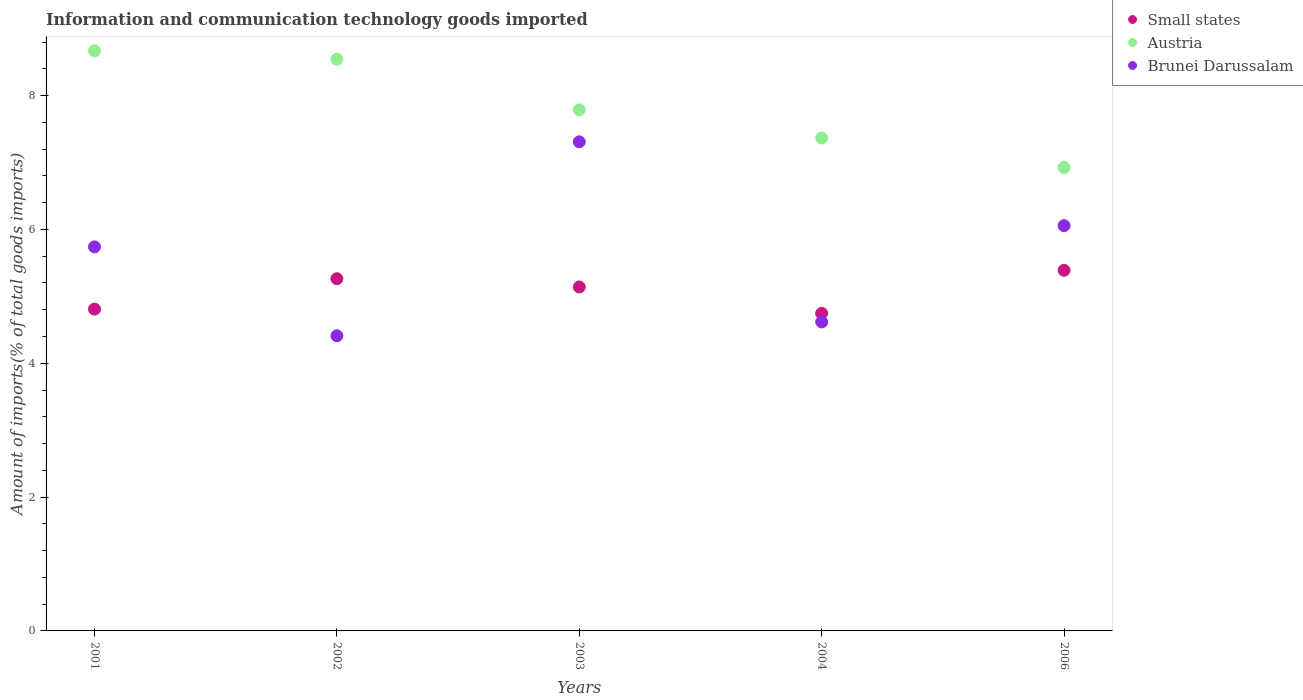What is the amount of goods imported in Small states in 2001?
Offer a very short reply. 4.81. Across all years, what is the maximum amount of goods imported in Brunei Darussalam?
Give a very brief answer. 7.31. Across all years, what is the minimum amount of goods imported in Small states?
Ensure brevity in your answer.  4.74. In which year was the amount of goods imported in Brunei Darussalam maximum?
Keep it short and to the point. 2003. What is the total amount of goods imported in Brunei Darussalam in the graph?
Keep it short and to the point. 28.13. What is the difference between the amount of goods imported in Austria in 2002 and that in 2006?
Make the answer very short. 1.62. What is the difference between the amount of goods imported in Austria in 2004 and the amount of goods imported in Small states in 2001?
Keep it short and to the point. 2.56. What is the average amount of goods imported in Austria per year?
Ensure brevity in your answer.  7.86. In the year 2004, what is the difference between the amount of goods imported in Austria and amount of goods imported in Brunei Darussalam?
Provide a succinct answer. 2.75. In how many years, is the amount of goods imported in Austria greater than 8.4 %?
Offer a very short reply. 2. What is the ratio of the amount of goods imported in Austria in 2003 to that in 2004?
Your response must be concise. 1.06. Is the amount of goods imported in Brunei Darussalam in 2003 less than that in 2004?
Keep it short and to the point. No. Is the difference between the amount of goods imported in Austria in 2003 and 2004 greater than the difference between the amount of goods imported in Brunei Darussalam in 2003 and 2004?
Offer a terse response. No. What is the difference between the highest and the second highest amount of goods imported in Brunei Darussalam?
Offer a terse response. 1.25. What is the difference between the highest and the lowest amount of goods imported in Austria?
Provide a short and direct response. 1.74. Does the amount of goods imported in Small states monotonically increase over the years?
Provide a short and direct response. No. Is the amount of goods imported in Brunei Darussalam strictly less than the amount of goods imported in Austria over the years?
Offer a very short reply. Yes. How many years are there in the graph?
Make the answer very short. 5. What is the difference between two consecutive major ticks on the Y-axis?
Provide a short and direct response. 2. Does the graph contain any zero values?
Give a very brief answer. No. How are the legend labels stacked?
Your answer should be compact. Vertical. What is the title of the graph?
Provide a short and direct response. Information and communication technology goods imported. What is the label or title of the Y-axis?
Offer a terse response. Amount of imports(% of total goods imports). What is the Amount of imports(% of total goods imports) of Small states in 2001?
Your answer should be very brief. 4.81. What is the Amount of imports(% of total goods imports) in Austria in 2001?
Provide a short and direct response. 8.67. What is the Amount of imports(% of total goods imports) of Brunei Darussalam in 2001?
Provide a succinct answer. 5.74. What is the Amount of imports(% of total goods imports) in Small states in 2002?
Provide a succinct answer. 5.26. What is the Amount of imports(% of total goods imports) in Austria in 2002?
Make the answer very short. 8.54. What is the Amount of imports(% of total goods imports) in Brunei Darussalam in 2002?
Keep it short and to the point. 4.41. What is the Amount of imports(% of total goods imports) in Small states in 2003?
Give a very brief answer. 5.14. What is the Amount of imports(% of total goods imports) of Austria in 2003?
Your answer should be compact. 7.79. What is the Amount of imports(% of total goods imports) in Brunei Darussalam in 2003?
Your answer should be compact. 7.31. What is the Amount of imports(% of total goods imports) in Small states in 2004?
Keep it short and to the point. 4.74. What is the Amount of imports(% of total goods imports) in Austria in 2004?
Offer a terse response. 7.37. What is the Amount of imports(% of total goods imports) of Brunei Darussalam in 2004?
Your answer should be very brief. 4.62. What is the Amount of imports(% of total goods imports) of Small states in 2006?
Ensure brevity in your answer.  5.39. What is the Amount of imports(% of total goods imports) of Austria in 2006?
Your answer should be very brief. 6.93. What is the Amount of imports(% of total goods imports) of Brunei Darussalam in 2006?
Make the answer very short. 6.06. Across all years, what is the maximum Amount of imports(% of total goods imports) in Small states?
Provide a succinct answer. 5.39. Across all years, what is the maximum Amount of imports(% of total goods imports) of Austria?
Your response must be concise. 8.67. Across all years, what is the maximum Amount of imports(% of total goods imports) in Brunei Darussalam?
Offer a very short reply. 7.31. Across all years, what is the minimum Amount of imports(% of total goods imports) of Small states?
Provide a short and direct response. 4.74. Across all years, what is the minimum Amount of imports(% of total goods imports) of Austria?
Your response must be concise. 6.93. Across all years, what is the minimum Amount of imports(% of total goods imports) in Brunei Darussalam?
Your answer should be very brief. 4.41. What is the total Amount of imports(% of total goods imports) of Small states in the graph?
Offer a terse response. 25.34. What is the total Amount of imports(% of total goods imports) in Austria in the graph?
Your answer should be compact. 39.29. What is the total Amount of imports(% of total goods imports) of Brunei Darussalam in the graph?
Make the answer very short. 28.13. What is the difference between the Amount of imports(% of total goods imports) of Small states in 2001 and that in 2002?
Offer a very short reply. -0.45. What is the difference between the Amount of imports(% of total goods imports) in Austria in 2001 and that in 2002?
Your answer should be very brief. 0.13. What is the difference between the Amount of imports(% of total goods imports) in Brunei Darussalam in 2001 and that in 2002?
Your answer should be compact. 1.33. What is the difference between the Amount of imports(% of total goods imports) of Small states in 2001 and that in 2003?
Offer a terse response. -0.33. What is the difference between the Amount of imports(% of total goods imports) of Austria in 2001 and that in 2003?
Offer a terse response. 0.88. What is the difference between the Amount of imports(% of total goods imports) of Brunei Darussalam in 2001 and that in 2003?
Make the answer very short. -1.57. What is the difference between the Amount of imports(% of total goods imports) in Small states in 2001 and that in 2004?
Provide a succinct answer. 0.06. What is the difference between the Amount of imports(% of total goods imports) in Austria in 2001 and that in 2004?
Provide a succinct answer. 1.3. What is the difference between the Amount of imports(% of total goods imports) of Brunei Darussalam in 2001 and that in 2004?
Offer a terse response. 1.12. What is the difference between the Amount of imports(% of total goods imports) of Small states in 2001 and that in 2006?
Provide a short and direct response. -0.58. What is the difference between the Amount of imports(% of total goods imports) in Austria in 2001 and that in 2006?
Your answer should be compact. 1.74. What is the difference between the Amount of imports(% of total goods imports) in Brunei Darussalam in 2001 and that in 2006?
Give a very brief answer. -0.32. What is the difference between the Amount of imports(% of total goods imports) of Small states in 2002 and that in 2003?
Provide a succinct answer. 0.12. What is the difference between the Amount of imports(% of total goods imports) of Austria in 2002 and that in 2003?
Provide a succinct answer. 0.76. What is the difference between the Amount of imports(% of total goods imports) in Brunei Darussalam in 2002 and that in 2003?
Ensure brevity in your answer.  -2.9. What is the difference between the Amount of imports(% of total goods imports) in Small states in 2002 and that in 2004?
Make the answer very short. 0.52. What is the difference between the Amount of imports(% of total goods imports) in Austria in 2002 and that in 2004?
Offer a terse response. 1.18. What is the difference between the Amount of imports(% of total goods imports) in Brunei Darussalam in 2002 and that in 2004?
Keep it short and to the point. -0.21. What is the difference between the Amount of imports(% of total goods imports) in Small states in 2002 and that in 2006?
Keep it short and to the point. -0.13. What is the difference between the Amount of imports(% of total goods imports) in Austria in 2002 and that in 2006?
Give a very brief answer. 1.62. What is the difference between the Amount of imports(% of total goods imports) in Brunei Darussalam in 2002 and that in 2006?
Keep it short and to the point. -1.65. What is the difference between the Amount of imports(% of total goods imports) in Small states in 2003 and that in 2004?
Your response must be concise. 0.39. What is the difference between the Amount of imports(% of total goods imports) in Austria in 2003 and that in 2004?
Offer a very short reply. 0.42. What is the difference between the Amount of imports(% of total goods imports) in Brunei Darussalam in 2003 and that in 2004?
Your answer should be very brief. 2.69. What is the difference between the Amount of imports(% of total goods imports) in Small states in 2003 and that in 2006?
Your answer should be very brief. -0.25. What is the difference between the Amount of imports(% of total goods imports) of Austria in 2003 and that in 2006?
Ensure brevity in your answer.  0.86. What is the difference between the Amount of imports(% of total goods imports) in Brunei Darussalam in 2003 and that in 2006?
Ensure brevity in your answer.  1.25. What is the difference between the Amount of imports(% of total goods imports) of Small states in 2004 and that in 2006?
Provide a succinct answer. -0.64. What is the difference between the Amount of imports(% of total goods imports) of Austria in 2004 and that in 2006?
Give a very brief answer. 0.44. What is the difference between the Amount of imports(% of total goods imports) of Brunei Darussalam in 2004 and that in 2006?
Give a very brief answer. -1.44. What is the difference between the Amount of imports(% of total goods imports) of Small states in 2001 and the Amount of imports(% of total goods imports) of Austria in 2002?
Ensure brevity in your answer.  -3.73. What is the difference between the Amount of imports(% of total goods imports) in Small states in 2001 and the Amount of imports(% of total goods imports) in Brunei Darussalam in 2002?
Provide a succinct answer. 0.4. What is the difference between the Amount of imports(% of total goods imports) in Austria in 2001 and the Amount of imports(% of total goods imports) in Brunei Darussalam in 2002?
Your answer should be compact. 4.26. What is the difference between the Amount of imports(% of total goods imports) in Small states in 2001 and the Amount of imports(% of total goods imports) in Austria in 2003?
Your response must be concise. -2.98. What is the difference between the Amount of imports(% of total goods imports) of Small states in 2001 and the Amount of imports(% of total goods imports) of Brunei Darussalam in 2003?
Provide a succinct answer. -2.5. What is the difference between the Amount of imports(% of total goods imports) in Austria in 2001 and the Amount of imports(% of total goods imports) in Brunei Darussalam in 2003?
Offer a very short reply. 1.36. What is the difference between the Amount of imports(% of total goods imports) of Small states in 2001 and the Amount of imports(% of total goods imports) of Austria in 2004?
Provide a succinct answer. -2.56. What is the difference between the Amount of imports(% of total goods imports) in Small states in 2001 and the Amount of imports(% of total goods imports) in Brunei Darussalam in 2004?
Provide a succinct answer. 0.19. What is the difference between the Amount of imports(% of total goods imports) in Austria in 2001 and the Amount of imports(% of total goods imports) in Brunei Darussalam in 2004?
Give a very brief answer. 4.05. What is the difference between the Amount of imports(% of total goods imports) of Small states in 2001 and the Amount of imports(% of total goods imports) of Austria in 2006?
Keep it short and to the point. -2.12. What is the difference between the Amount of imports(% of total goods imports) in Small states in 2001 and the Amount of imports(% of total goods imports) in Brunei Darussalam in 2006?
Give a very brief answer. -1.25. What is the difference between the Amount of imports(% of total goods imports) in Austria in 2001 and the Amount of imports(% of total goods imports) in Brunei Darussalam in 2006?
Offer a terse response. 2.61. What is the difference between the Amount of imports(% of total goods imports) of Small states in 2002 and the Amount of imports(% of total goods imports) of Austria in 2003?
Your answer should be compact. -2.52. What is the difference between the Amount of imports(% of total goods imports) in Small states in 2002 and the Amount of imports(% of total goods imports) in Brunei Darussalam in 2003?
Provide a succinct answer. -2.05. What is the difference between the Amount of imports(% of total goods imports) in Austria in 2002 and the Amount of imports(% of total goods imports) in Brunei Darussalam in 2003?
Provide a succinct answer. 1.23. What is the difference between the Amount of imports(% of total goods imports) in Small states in 2002 and the Amount of imports(% of total goods imports) in Austria in 2004?
Offer a terse response. -2.1. What is the difference between the Amount of imports(% of total goods imports) in Small states in 2002 and the Amount of imports(% of total goods imports) in Brunei Darussalam in 2004?
Make the answer very short. 0.65. What is the difference between the Amount of imports(% of total goods imports) in Austria in 2002 and the Amount of imports(% of total goods imports) in Brunei Darussalam in 2004?
Your response must be concise. 3.93. What is the difference between the Amount of imports(% of total goods imports) of Small states in 2002 and the Amount of imports(% of total goods imports) of Austria in 2006?
Your answer should be very brief. -1.66. What is the difference between the Amount of imports(% of total goods imports) in Small states in 2002 and the Amount of imports(% of total goods imports) in Brunei Darussalam in 2006?
Provide a succinct answer. -0.79. What is the difference between the Amount of imports(% of total goods imports) in Austria in 2002 and the Amount of imports(% of total goods imports) in Brunei Darussalam in 2006?
Your response must be concise. 2.49. What is the difference between the Amount of imports(% of total goods imports) in Small states in 2003 and the Amount of imports(% of total goods imports) in Austria in 2004?
Give a very brief answer. -2.23. What is the difference between the Amount of imports(% of total goods imports) in Small states in 2003 and the Amount of imports(% of total goods imports) in Brunei Darussalam in 2004?
Your answer should be compact. 0.52. What is the difference between the Amount of imports(% of total goods imports) of Austria in 2003 and the Amount of imports(% of total goods imports) of Brunei Darussalam in 2004?
Provide a succinct answer. 3.17. What is the difference between the Amount of imports(% of total goods imports) of Small states in 2003 and the Amount of imports(% of total goods imports) of Austria in 2006?
Provide a succinct answer. -1.79. What is the difference between the Amount of imports(% of total goods imports) in Small states in 2003 and the Amount of imports(% of total goods imports) in Brunei Darussalam in 2006?
Offer a very short reply. -0.92. What is the difference between the Amount of imports(% of total goods imports) in Austria in 2003 and the Amount of imports(% of total goods imports) in Brunei Darussalam in 2006?
Ensure brevity in your answer.  1.73. What is the difference between the Amount of imports(% of total goods imports) in Small states in 2004 and the Amount of imports(% of total goods imports) in Austria in 2006?
Make the answer very short. -2.18. What is the difference between the Amount of imports(% of total goods imports) of Small states in 2004 and the Amount of imports(% of total goods imports) of Brunei Darussalam in 2006?
Make the answer very short. -1.31. What is the difference between the Amount of imports(% of total goods imports) in Austria in 2004 and the Amount of imports(% of total goods imports) in Brunei Darussalam in 2006?
Your answer should be very brief. 1.31. What is the average Amount of imports(% of total goods imports) in Small states per year?
Provide a succinct answer. 5.07. What is the average Amount of imports(% of total goods imports) in Austria per year?
Provide a short and direct response. 7.86. What is the average Amount of imports(% of total goods imports) of Brunei Darussalam per year?
Offer a terse response. 5.63. In the year 2001, what is the difference between the Amount of imports(% of total goods imports) of Small states and Amount of imports(% of total goods imports) of Austria?
Provide a succinct answer. -3.86. In the year 2001, what is the difference between the Amount of imports(% of total goods imports) in Small states and Amount of imports(% of total goods imports) in Brunei Darussalam?
Your answer should be very brief. -0.93. In the year 2001, what is the difference between the Amount of imports(% of total goods imports) in Austria and Amount of imports(% of total goods imports) in Brunei Darussalam?
Keep it short and to the point. 2.93. In the year 2002, what is the difference between the Amount of imports(% of total goods imports) of Small states and Amount of imports(% of total goods imports) of Austria?
Ensure brevity in your answer.  -3.28. In the year 2002, what is the difference between the Amount of imports(% of total goods imports) in Small states and Amount of imports(% of total goods imports) in Brunei Darussalam?
Give a very brief answer. 0.85. In the year 2002, what is the difference between the Amount of imports(% of total goods imports) in Austria and Amount of imports(% of total goods imports) in Brunei Darussalam?
Your answer should be very brief. 4.13. In the year 2003, what is the difference between the Amount of imports(% of total goods imports) of Small states and Amount of imports(% of total goods imports) of Austria?
Your answer should be compact. -2.65. In the year 2003, what is the difference between the Amount of imports(% of total goods imports) in Small states and Amount of imports(% of total goods imports) in Brunei Darussalam?
Ensure brevity in your answer.  -2.17. In the year 2003, what is the difference between the Amount of imports(% of total goods imports) of Austria and Amount of imports(% of total goods imports) of Brunei Darussalam?
Your answer should be very brief. 0.48. In the year 2004, what is the difference between the Amount of imports(% of total goods imports) in Small states and Amount of imports(% of total goods imports) in Austria?
Offer a very short reply. -2.62. In the year 2004, what is the difference between the Amount of imports(% of total goods imports) in Small states and Amount of imports(% of total goods imports) in Brunei Darussalam?
Offer a very short reply. 0.13. In the year 2004, what is the difference between the Amount of imports(% of total goods imports) of Austria and Amount of imports(% of total goods imports) of Brunei Darussalam?
Provide a succinct answer. 2.75. In the year 2006, what is the difference between the Amount of imports(% of total goods imports) of Small states and Amount of imports(% of total goods imports) of Austria?
Keep it short and to the point. -1.54. In the year 2006, what is the difference between the Amount of imports(% of total goods imports) in Small states and Amount of imports(% of total goods imports) in Brunei Darussalam?
Offer a very short reply. -0.67. In the year 2006, what is the difference between the Amount of imports(% of total goods imports) in Austria and Amount of imports(% of total goods imports) in Brunei Darussalam?
Offer a terse response. 0.87. What is the ratio of the Amount of imports(% of total goods imports) in Small states in 2001 to that in 2002?
Give a very brief answer. 0.91. What is the ratio of the Amount of imports(% of total goods imports) in Austria in 2001 to that in 2002?
Offer a terse response. 1.01. What is the ratio of the Amount of imports(% of total goods imports) of Brunei Darussalam in 2001 to that in 2002?
Give a very brief answer. 1.3. What is the ratio of the Amount of imports(% of total goods imports) of Small states in 2001 to that in 2003?
Provide a short and direct response. 0.94. What is the ratio of the Amount of imports(% of total goods imports) of Austria in 2001 to that in 2003?
Give a very brief answer. 1.11. What is the ratio of the Amount of imports(% of total goods imports) in Brunei Darussalam in 2001 to that in 2003?
Offer a very short reply. 0.79. What is the ratio of the Amount of imports(% of total goods imports) in Small states in 2001 to that in 2004?
Provide a succinct answer. 1.01. What is the ratio of the Amount of imports(% of total goods imports) of Austria in 2001 to that in 2004?
Ensure brevity in your answer.  1.18. What is the ratio of the Amount of imports(% of total goods imports) of Brunei Darussalam in 2001 to that in 2004?
Keep it short and to the point. 1.24. What is the ratio of the Amount of imports(% of total goods imports) of Small states in 2001 to that in 2006?
Offer a terse response. 0.89. What is the ratio of the Amount of imports(% of total goods imports) in Austria in 2001 to that in 2006?
Provide a succinct answer. 1.25. What is the ratio of the Amount of imports(% of total goods imports) of Brunei Darussalam in 2001 to that in 2006?
Keep it short and to the point. 0.95. What is the ratio of the Amount of imports(% of total goods imports) in Austria in 2002 to that in 2003?
Keep it short and to the point. 1.1. What is the ratio of the Amount of imports(% of total goods imports) of Brunei Darussalam in 2002 to that in 2003?
Your answer should be compact. 0.6. What is the ratio of the Amount of imports(% of total goods imports) in Small states in 2002 to that in 2004?
Keep it short and to the point. 1.11. What is the ratio of the Amount of imports(% of total goods imports) in Austria in 2002 to that in 2004?
Provide a short and direct response. 1.16. What is the ratio of the Amount of imports(% of total goods imports) of Brunei Darussalam in 2002 to that in 2004?
Provide a succinct answer. 0.96. What is the ratio of the Amount of imports(% of total goods imports) in Small states in 2002 to that in 2006?
Your answer should be compact. 0.98. What is the ratio of the Amount of imports(% of total goods imports) in Austria in 2002 to that in 2006?
Keep it short and to the point. 1.23. What is the ratio of the Amount of imports(% of total goods imports) in Brunei Darussalam in 2002 to that in 2006?
Offer a very short reply. 0.73. What is the ratio of the Amount of imports(% of total goods imports) in Small states in 2003 to that in 2004?
Your response must be concise. 1.08. What is the ratio of the Amount of imports(% of total goods imports) of Austria in 2003 to that in 2004?
Keep it short and to the point. 1.06. What is the ratio of the Amount of imports(% of total goods imports) in Brunei Darussalam in 2003 to that in 2004?
Your response must be concise. 1.58. What is the ratio of the Amount of imports(% of total goods imports) of Small states in 2003 to that in 2006?
Your answer should be very brief. 0.95. What is the ratio of the Amount of imports(% of total goods imports) in Austria in 2003 to that in 2006?
Offer a very short reply. 1.12. What is the ratio of the Amount of imports(% of total goods imports) of Brunei Darussalam in 2003 to that in 2006?
Make the answer very short. 1.21. What is the ratio of the Amount of imports(% of total goods imports) of Small states in 2004 to that in 2006?
Provide a short and direct response. 0.88. What is the ratio of the Amount of imports(% of total goods imports) in Austria in 2004 to that in 2006?
Give a very brief answer. 1.06. What is the ratio of the Amount of imports(% of total goods imports) in Brunei Darussalam in 2004 to that in 2006?
Give a very brief answer. 0.76. What is the difference between the highest and the second highest Amount of imports(% of total goods imports) of Small states?
Your response must be concise. 0.13. What is the difference between the highest and the second highest Amount of imports(% of total goods imports) of Austria?
Give a very brief answer. 0.13. What is the difference between the highest and the second highest Amount of imports(% of total goods imports) of Brunei Darussalam?
Keep it short and to the point. 1.25. What is the difference between the highest and the lowest Amount of imports(% of total goods imports) of Small states?
Ensure brevity in your answer.  0.64. What is the difference between the highest and the lowest Amount of imports(% of total goods imports) of Austria?
Your answer should be compact. 1.74. What is the difference between the highest and the lowest Amount of imports(% of total goods imports) of Brunei Darussalam?
Your answer should be very brief. 2.9. 